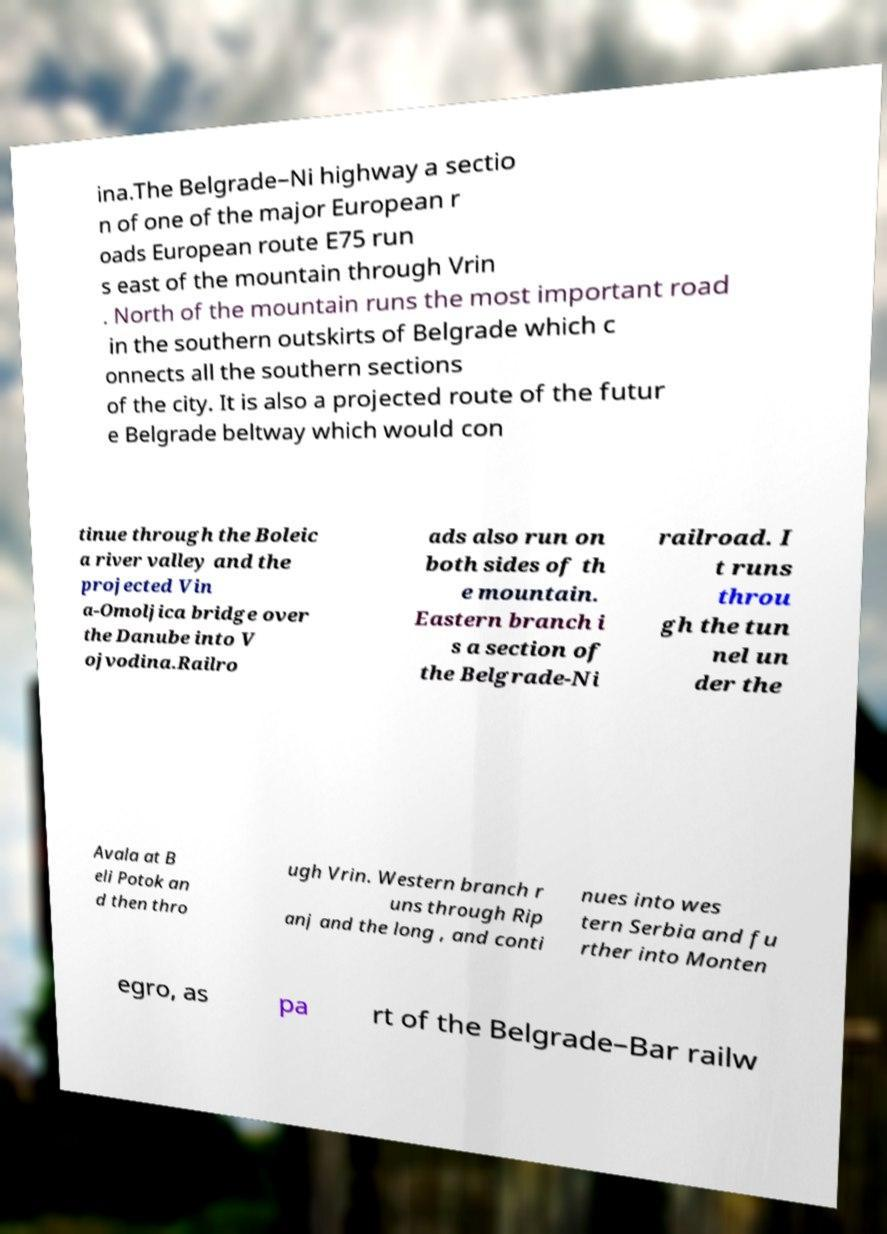Please read and relay the text visible in this image. What does it say? ina.The Belgrade–Ni highway a sectio n of one of the major European r oads European route E75 run s east of the mountain through Vrin . North of the mountain runs the most important road in the southern outskirts of Belgrade which c onnects all the southern sections of the city. It is also a projected route of the futur e Belgrade beltway which would con tinue through the Boleic a river valley and the projected Vin a-Omoljica bridge over the Danube into V ojvodina.Railro ads also run on both sides of th e mountain. Eastern branch i s a section of the Belgrade-Ni railroad. I t runs throu gh the tun nel un der the Avala at B eli Potok an d then thro ugh Vrin. Western branch r uns through Rip anj and the long , and conti nues into wes tern Serbia and fu rther into Monten egro, as pa rt of the Belgrade–Bar railw 